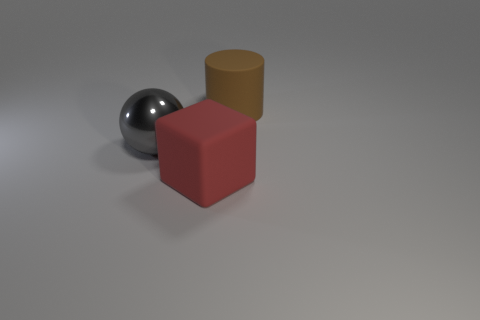Are there any other things that are the same material as the big sphere?
Give a very brief answer. No. What number of brown matte cylinders are to the right of the matte thing behind the large rubber object that is in front of the brown rubber cylinder?
Offer a terse response. 0. What number of spheres are large metallic objects or purple objects?
Offer a terse response. 1. The gray metallic object has what shape?
Offer a terse response. Sphere. There is a red rubber cube; are there any big spheres in front of it?
Ensure brevity in your answer.  No. Do the big cylinder and the large object on the left side of the large red cube have the same material?
Ensure brevity in your answer.  No. What number of other big blocks are the same material as the red cube?
Your response must be concise. 0. What number of objects are either big objects that are in front of the big metallic ball or cyan metal balls?
Provide a short and direct response. 1. How big is the brown cylinder?
Make the answer very short. Large. The object left of the big rubber thing on the left side of the brown object is made of what material?
Offer a very short reply. Metal. 